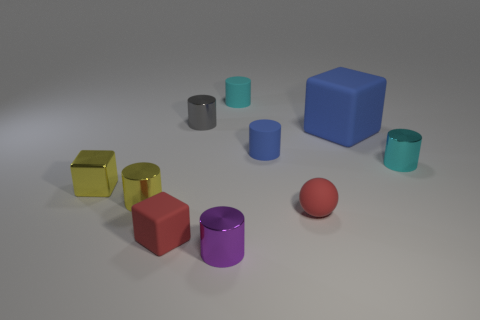Subtract all tiny cubes. How many cubes are left? 1 Subtract 5 cylinders. How many cylinders are left? 1 Subtract all blocks. How many objects are left? 7 Subtract all gray spheres. How many blue blocks are left? 1 Subtract all balls. Subtract all purple objects. How many objects are left? 8 Add 9 tiny gray cylinders. How many tiny gray cylinders are left? 10 Add 3 metal cylinders. How many metal cylinders exist? 7 Subtract all gray cylinders. How many cylinders are left? 5 Subtract 0 purple cubes. How many objects are left? 10 Subtract all gray spheres. Subtract all cyan cylinders. How many spheres are left? 1 